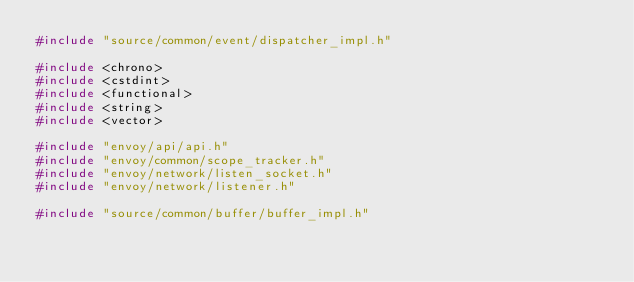Convert code to text. <code><loc_0><loc_0><loc_500><loc_500><_C++_>#include "source/common/event/dispatcher_impl.h"

#include <chrono>
#include <cstdint>
#include <functional>
#include <string>
#include <vector>

#include "envoy/api/api.h"
#include "envoy/common/scope_tracker.h"
#include "envoy/network/listen_socket.h"
#include "envoy/network/listener.h"

#include "source/common/buffer/buffer_impl.h"</code> 